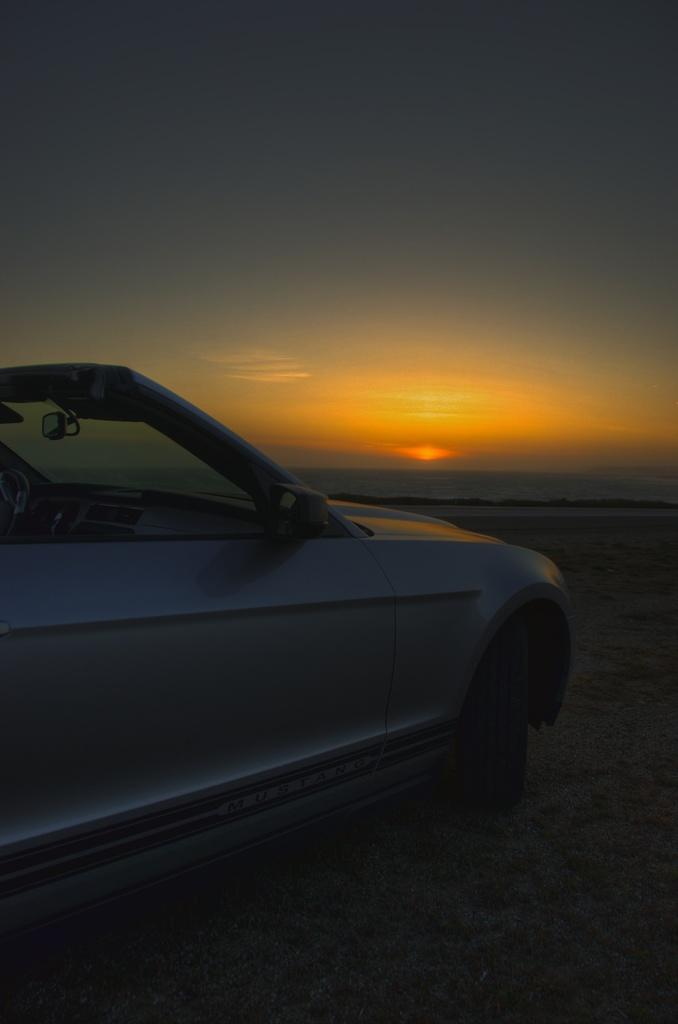What is the main subject of the image? There is a vehicle in the image. Where is the vehicle located? The vehicle is on the sand. What can be seen in the background of the image? There is water, the sun, and the sky visible in the background of the image. What type of pie is being served in the image? There is no pie present in the image; it features a vehicle on the sand with a background of water, the sun, and the sky. How many balloons are tied to the vehicle in the image? There are no balloons present in the image; it only shows a vehicle on the sand with a background of water, the sun, and the sky. 